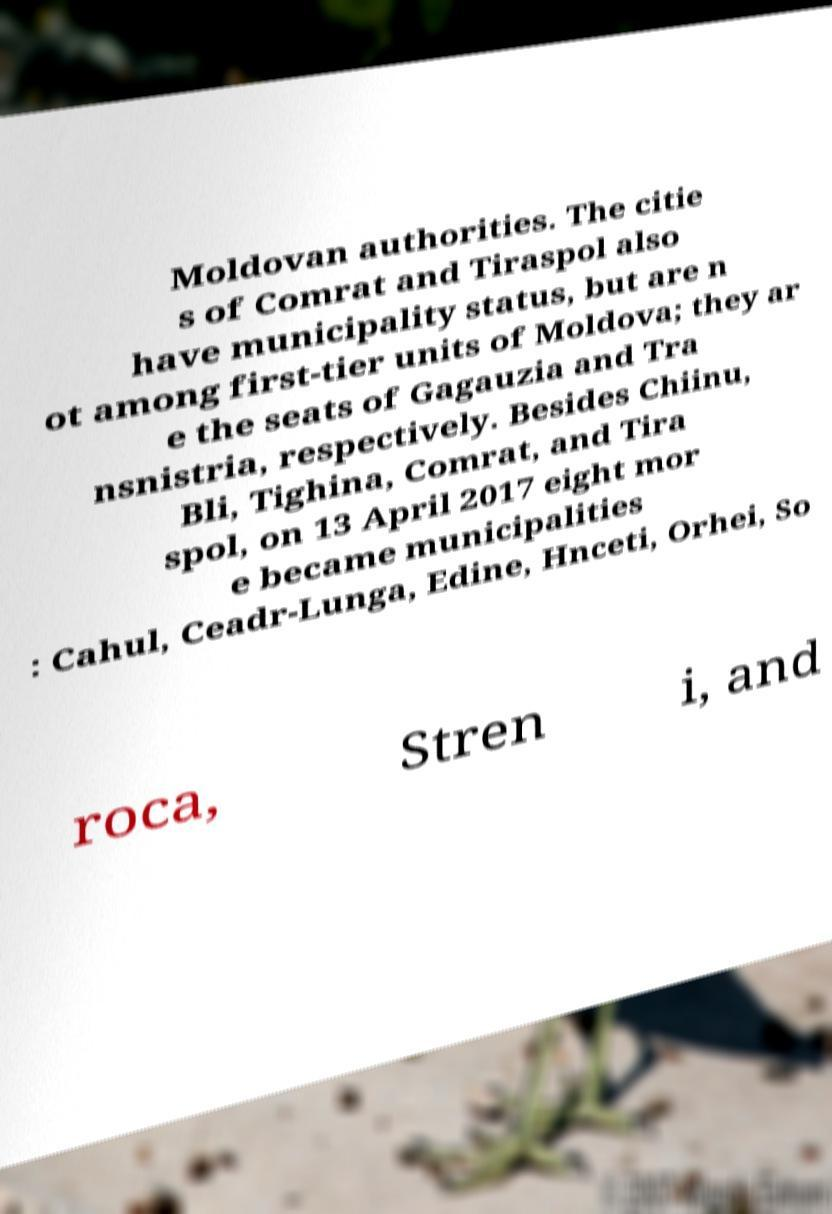Could you assist in decoding the text presented in this image and type it out clearly? Moldovan authorities. The citie s of Comrat and Tiraspol also have municipality status, but are n ot among first-tier units of Moldova; they ar e the seats of Gagauzia and Tra nsnistria, respectively. Besides Chiinu, Bli, Tighina, Comrat, and Tira spol, on 13 April 2017 eight mor e became municipalities : Cahul, Ceadr-Lunga, Edine, Hnceti, Orhei, So roca, Stren i, and 